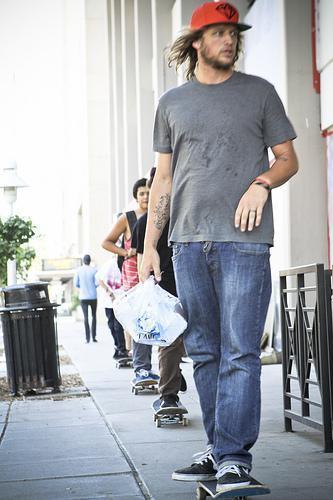How many people wearing an orange hat?
Give a very brief answer. 1. 